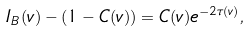<formula> <loc_0><loc_0><loc_500><loc_500>I _ { B } ( v ) - ( 1 - C ( v ) ) = C ( v ) e ^ { - 2 \tau ( v ) } ,</formula> 